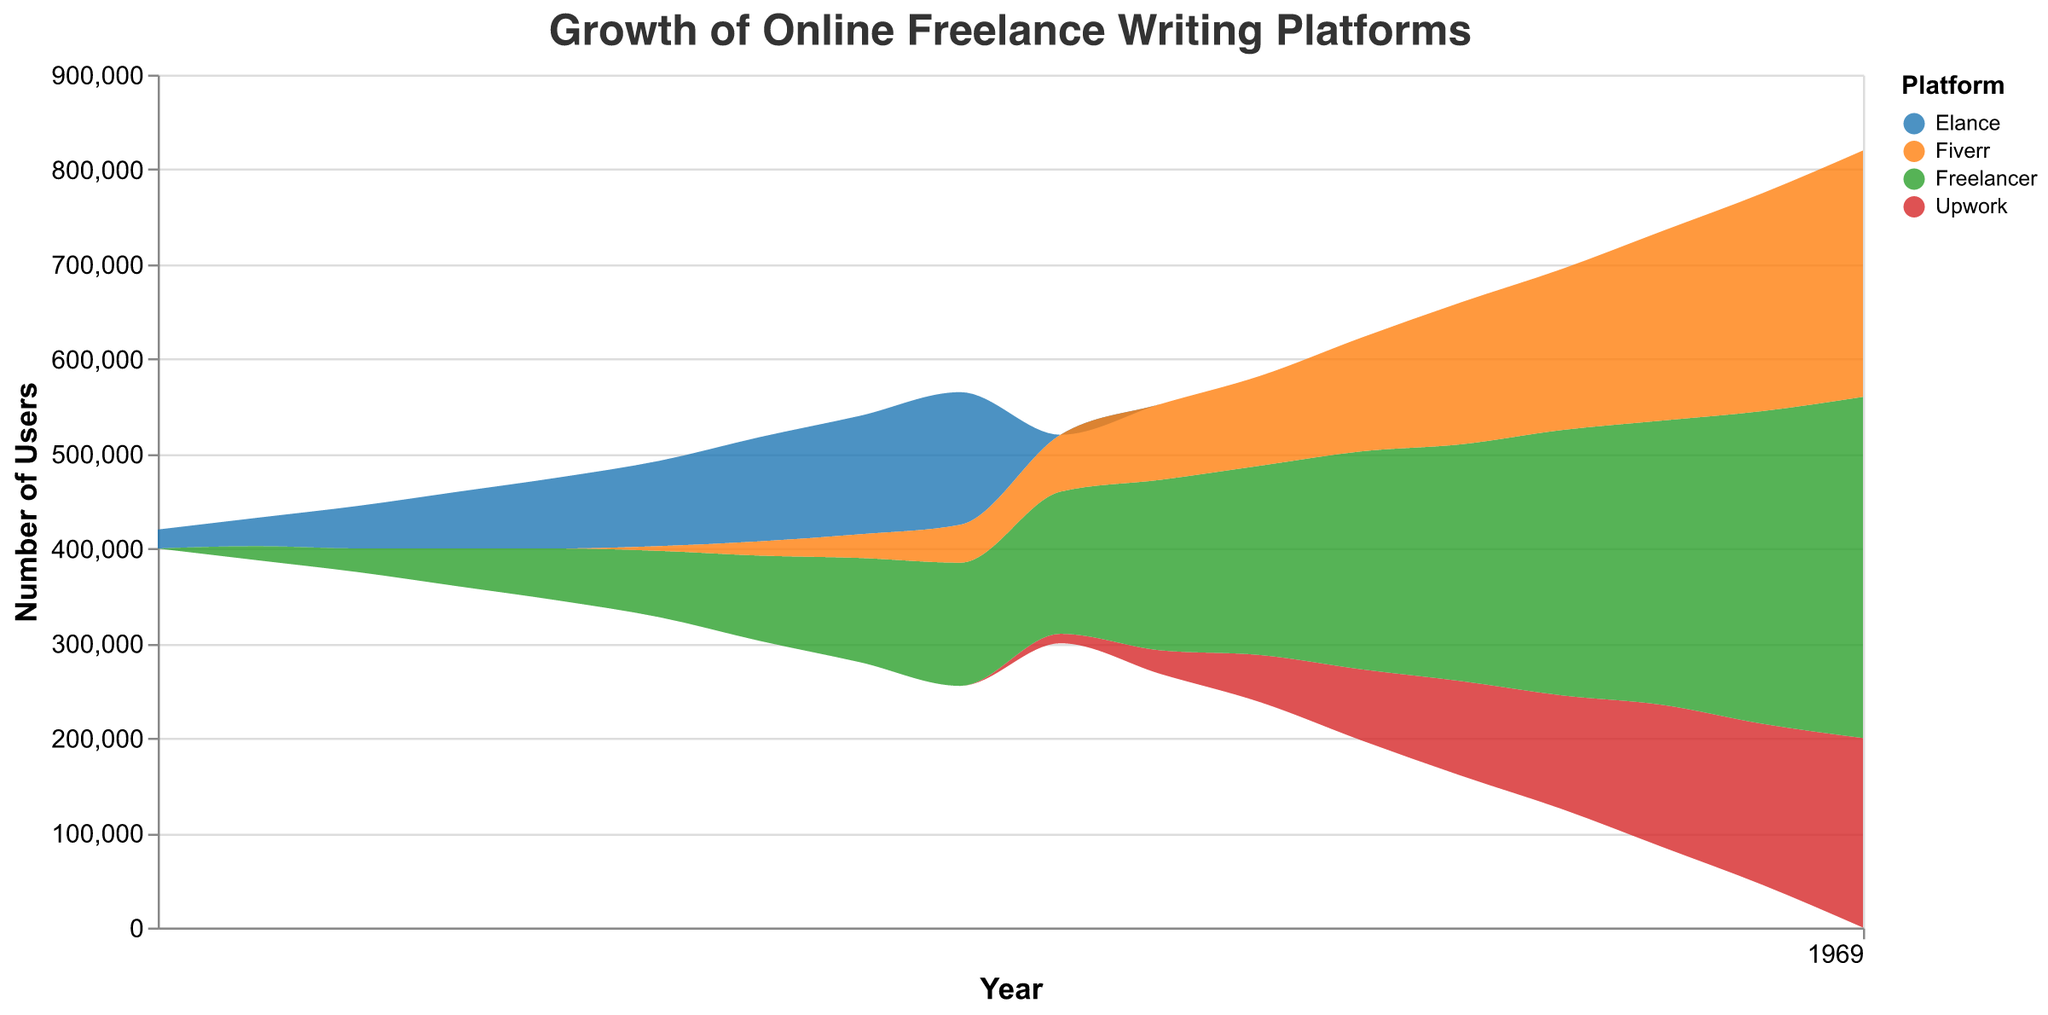What is the title of the graph? The title of the graph is displayed at the top and provides a description of what the graph represents.
Answer: Growth of Online Freelance Writing Platforms Which platform had the highest number of users in 2022? By looking at the graph for the year 2022, identify which platform has the highest vertical extent (representing user count).
Answer: Freelancer What trend can be observed for Elance from 2005 to 2013? Examine the portion of the graph corresponding to Elance from 2005 to 2013 to determine if the number of users generally increased, decreased, or stayed the same.
Answer: Increased How did the number of users for Upwork change from 2014 to 2022? Look at the graphical representation of Upwork's user count from 2014 to 2022 to determine if it increased, decreased, or stayed the same over this period.
Answer: Increased Compare the user growth of Fiverr and Freelancer from 2010 to 2022. Which platform grew more significantly? Calculate the difference in user counts for both Fiverr and Freelancer between 2010 and 2022, then compare these differences.
Answer: Freelancer What noticeable change occurs in the coloring of the graph between 2013 and 2014? Observe the colors in the graph around the year 2013 to 2014 to identify any significant changes in platform representation.
Answer: Transition from Elance to Upwork What is the total number of users across all platforms in 2019? Sum the user counts for all platforms for the year 2019 as represented in the graph.
Answer: 670,000 Which platform started showing significant growth earliest? Identify which platform first shows a noticeable upward trend in user count.
Answer: Elance Between which years did Freelancer see the most rapid increase in users? Find the period during which Freelancer's slope (indicating user growth rate) is steepest in the graph.
Answer: 2018 to 2022 How does the growth pattern of Upwork compare with Elance after 2014? Examine the user count trends for Elance and Upwork to compare their growth patterns post-2014 when Upwork appears.
Answer: Upwork shows increasing growth, while Elance is not present 